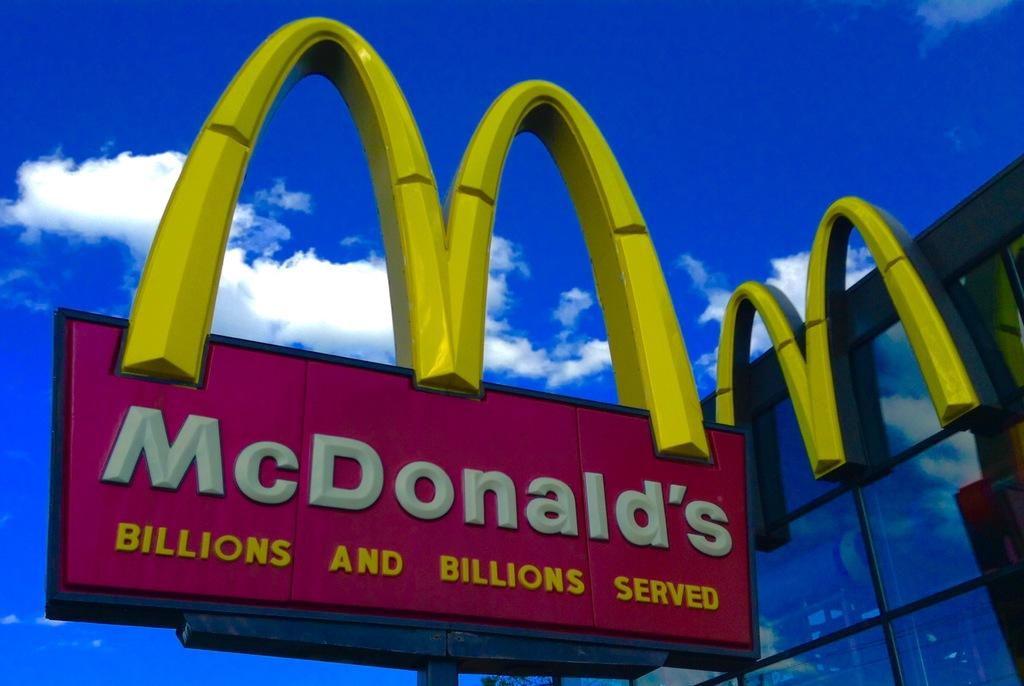<image>
Render a clear and concise summary of the photo. A large Mcdonald's sign with a blue sky in the background. 